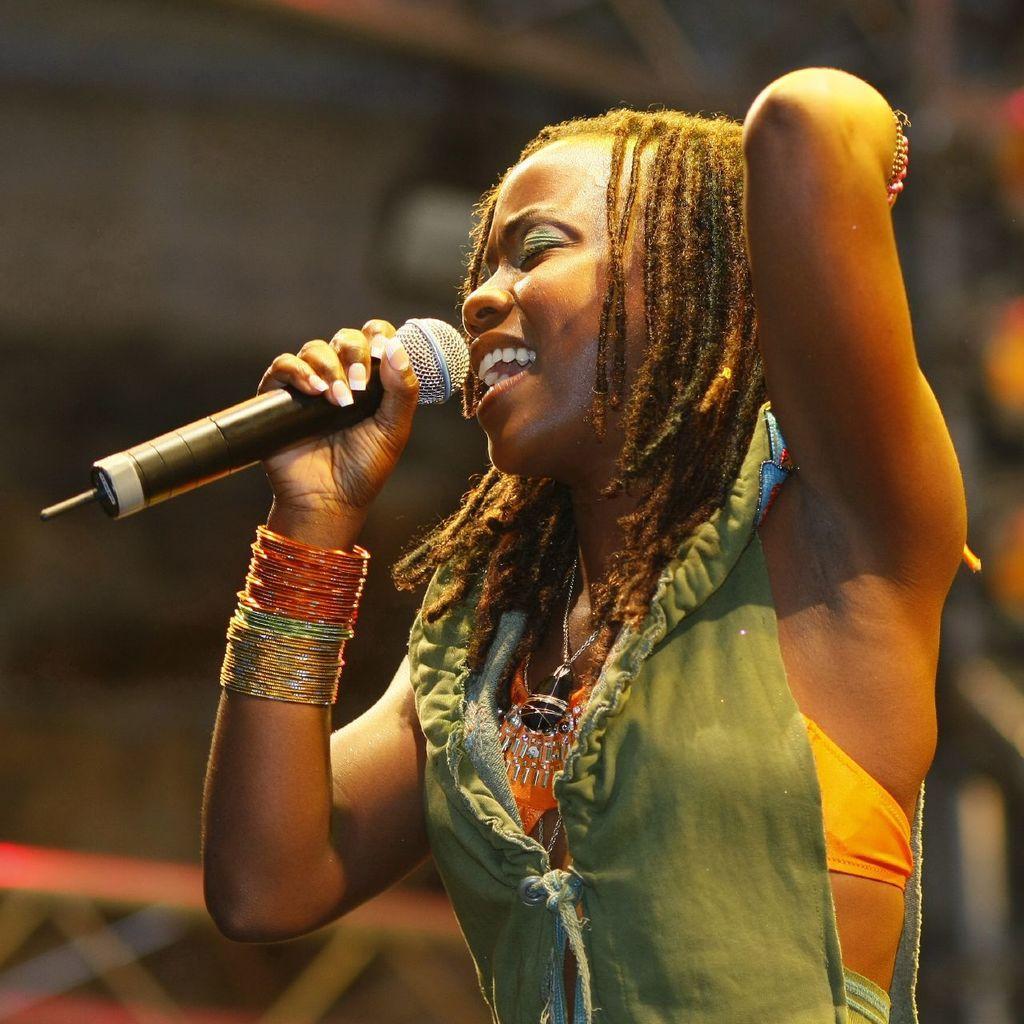In one or two sentences, can you explain what this image depicts? In the center we can see a lady she is singing and holding the microphone. We can see her mouth is open. 